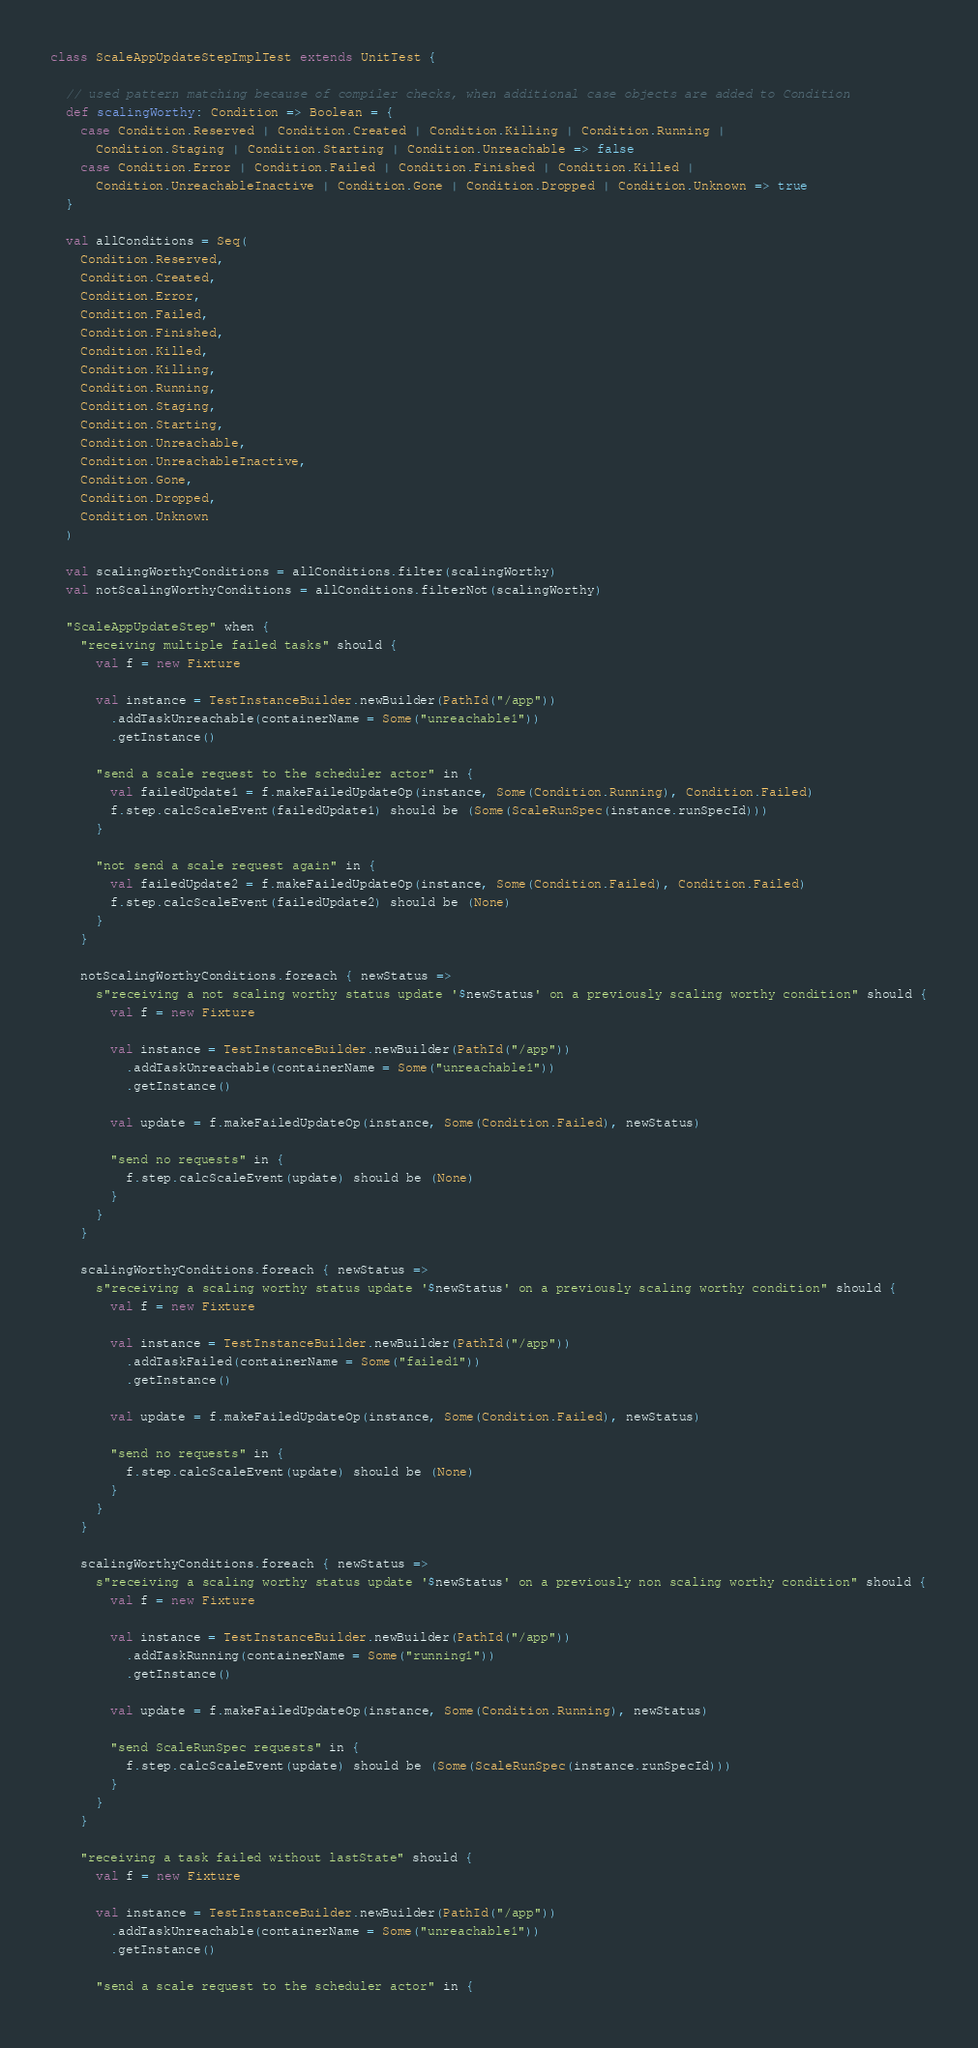Convert code to text. <code><loc_0><loc_0><loc_500><loc_500><_Scala_>
class ScaleAppUpdateStepImplTest extends UnitTest {

  // used pattern matching because of compiler checks, when additional case objects are added to Condition
  def scalingWorthy: Condition => Boolean = {
    case Condition.Reserved | Condition.Created | Condition.Killing | Condition.Running |
      Condition.Staging | Condition.Starting | Condition.Unreachable => false
    case Condition.Error | Condition.Failed | Condition.Finished | Condition.Killed |
      Condition.UnreachableInactive | Condition.Gone | Condition.Dropped | Condition.Unknown => true
  }

  val allConditions = Seq(
    Condition.Reserved,
    Condition.Created,
    Condition.Error,
    Condition.Failed,
    Condition.Finished,
    Condition.Killed,
    Condition.Killing,
    Condition.Running,
    Condition.Staging,
    Condition.Starting,
    Condition.Unreachable,
    Condition.UnreachableInactive,
    Condition.Gone,
    Condition.Dropped,
    Condition.Unknown
  )

  val scalingWorthyConditions = allConditions.filter(scalingWorthy)
  val notScalingWorthyConditions = allConditions.filterNot(scalingWorthy)

  "ScaleAppUpdateStep" when {
    "receiving multiple failed tasks" should {
      val f = new Fixture

      val instance = TestInstanceBuilder.newBuilder(PathId("/app"))
        .addTaskUnreachable(containerName = Some("unreachable1"))
        .getInstance()

      "send a scale request to the scheduler actor" in {
        val failedUpdate1 = f.makeFailedUpdateOp(instance, Some(Condition.Running), Condition.Failed)
        f.step.calcScaleEvent(failedUpdate1) should be (Some(ScaleRunSpec(instance.runSpecId)))
      }

      "not send a scale request again" in {
        val failedUpdate2 = f.makeFailedUpdateOp(instance, Some(Condition.Failed), Condition.Failed)
        f.step.calcScaleEvent(failedUpdate2) should be (None)
      }
    }

    notScalingWorthyConditions.foreach { newStatus =>
      s"receiving a not scaling worthy status update '$newStatus' on a previously scaling worthy condition" should {
        val f = new Fixture

        val instance = TestInstanceBuilder.newBuilder(PathId("/app"))
          .addTaskUnreachable(containerName = Some("unreachable1"))
          .getInstance()

        val update = f.makeFailedUpdateOp(instance, Some(Condition.Failed), newStatus)

        "send no requests" in {
          f.step.calcScaleEvent(update) should be (None)
        }
      }
    }

    scalingWorthyConditions.foreach { newStatus =>
      s"receiving a scaling worthy status update '$newStatus' on a previously scaling worthy condition" should {
        val f = new Fixture

        val instance = TestInstanceBuilder.newBuilder(PathId("/app"))
          .addTaskFailed(containerName = Some("failed1"))
          .getInstance()

        val update = f.makeFailedUpdateOp(instance, Some(Condition.Failed), newStatus)

        "send no requests" in {
          f.step.calcScaleEvent(update) should be (None)
        }
      }
    }

    scalingWorthyConditions.foreach { newStatus =>
      s"receiving a scaling worthy status update '$newStatus' on a previously non scaling worthy condition" should {
        val f = new Fixture

        val instance = TestInstanceBuilder.newBuilder(PathId("/app"))
          .addTaskRunning(containerName = Some("running1"))
          .getInstance()

        val update = f.makeFailedUpdateOp(instance, Some(Condition.Running), newStatus)

        "send ScaleRunSpec requests" in {
          f.step.calcScaleEvent(update) should be (Some(ScaleRunSpec(instance.runSpecId)))
        }
      }
    }

    "receiving a task failed without lastState" should {
      val f = new Fixture

      val instance = TestInstanceBuilder.newBuilder(PathId("/app"))
        .addTaskUnreachable(containerName = Some("unreachable1"))
        .getInstance()

      "send a scale request to the scheduler actor" in {</code> 